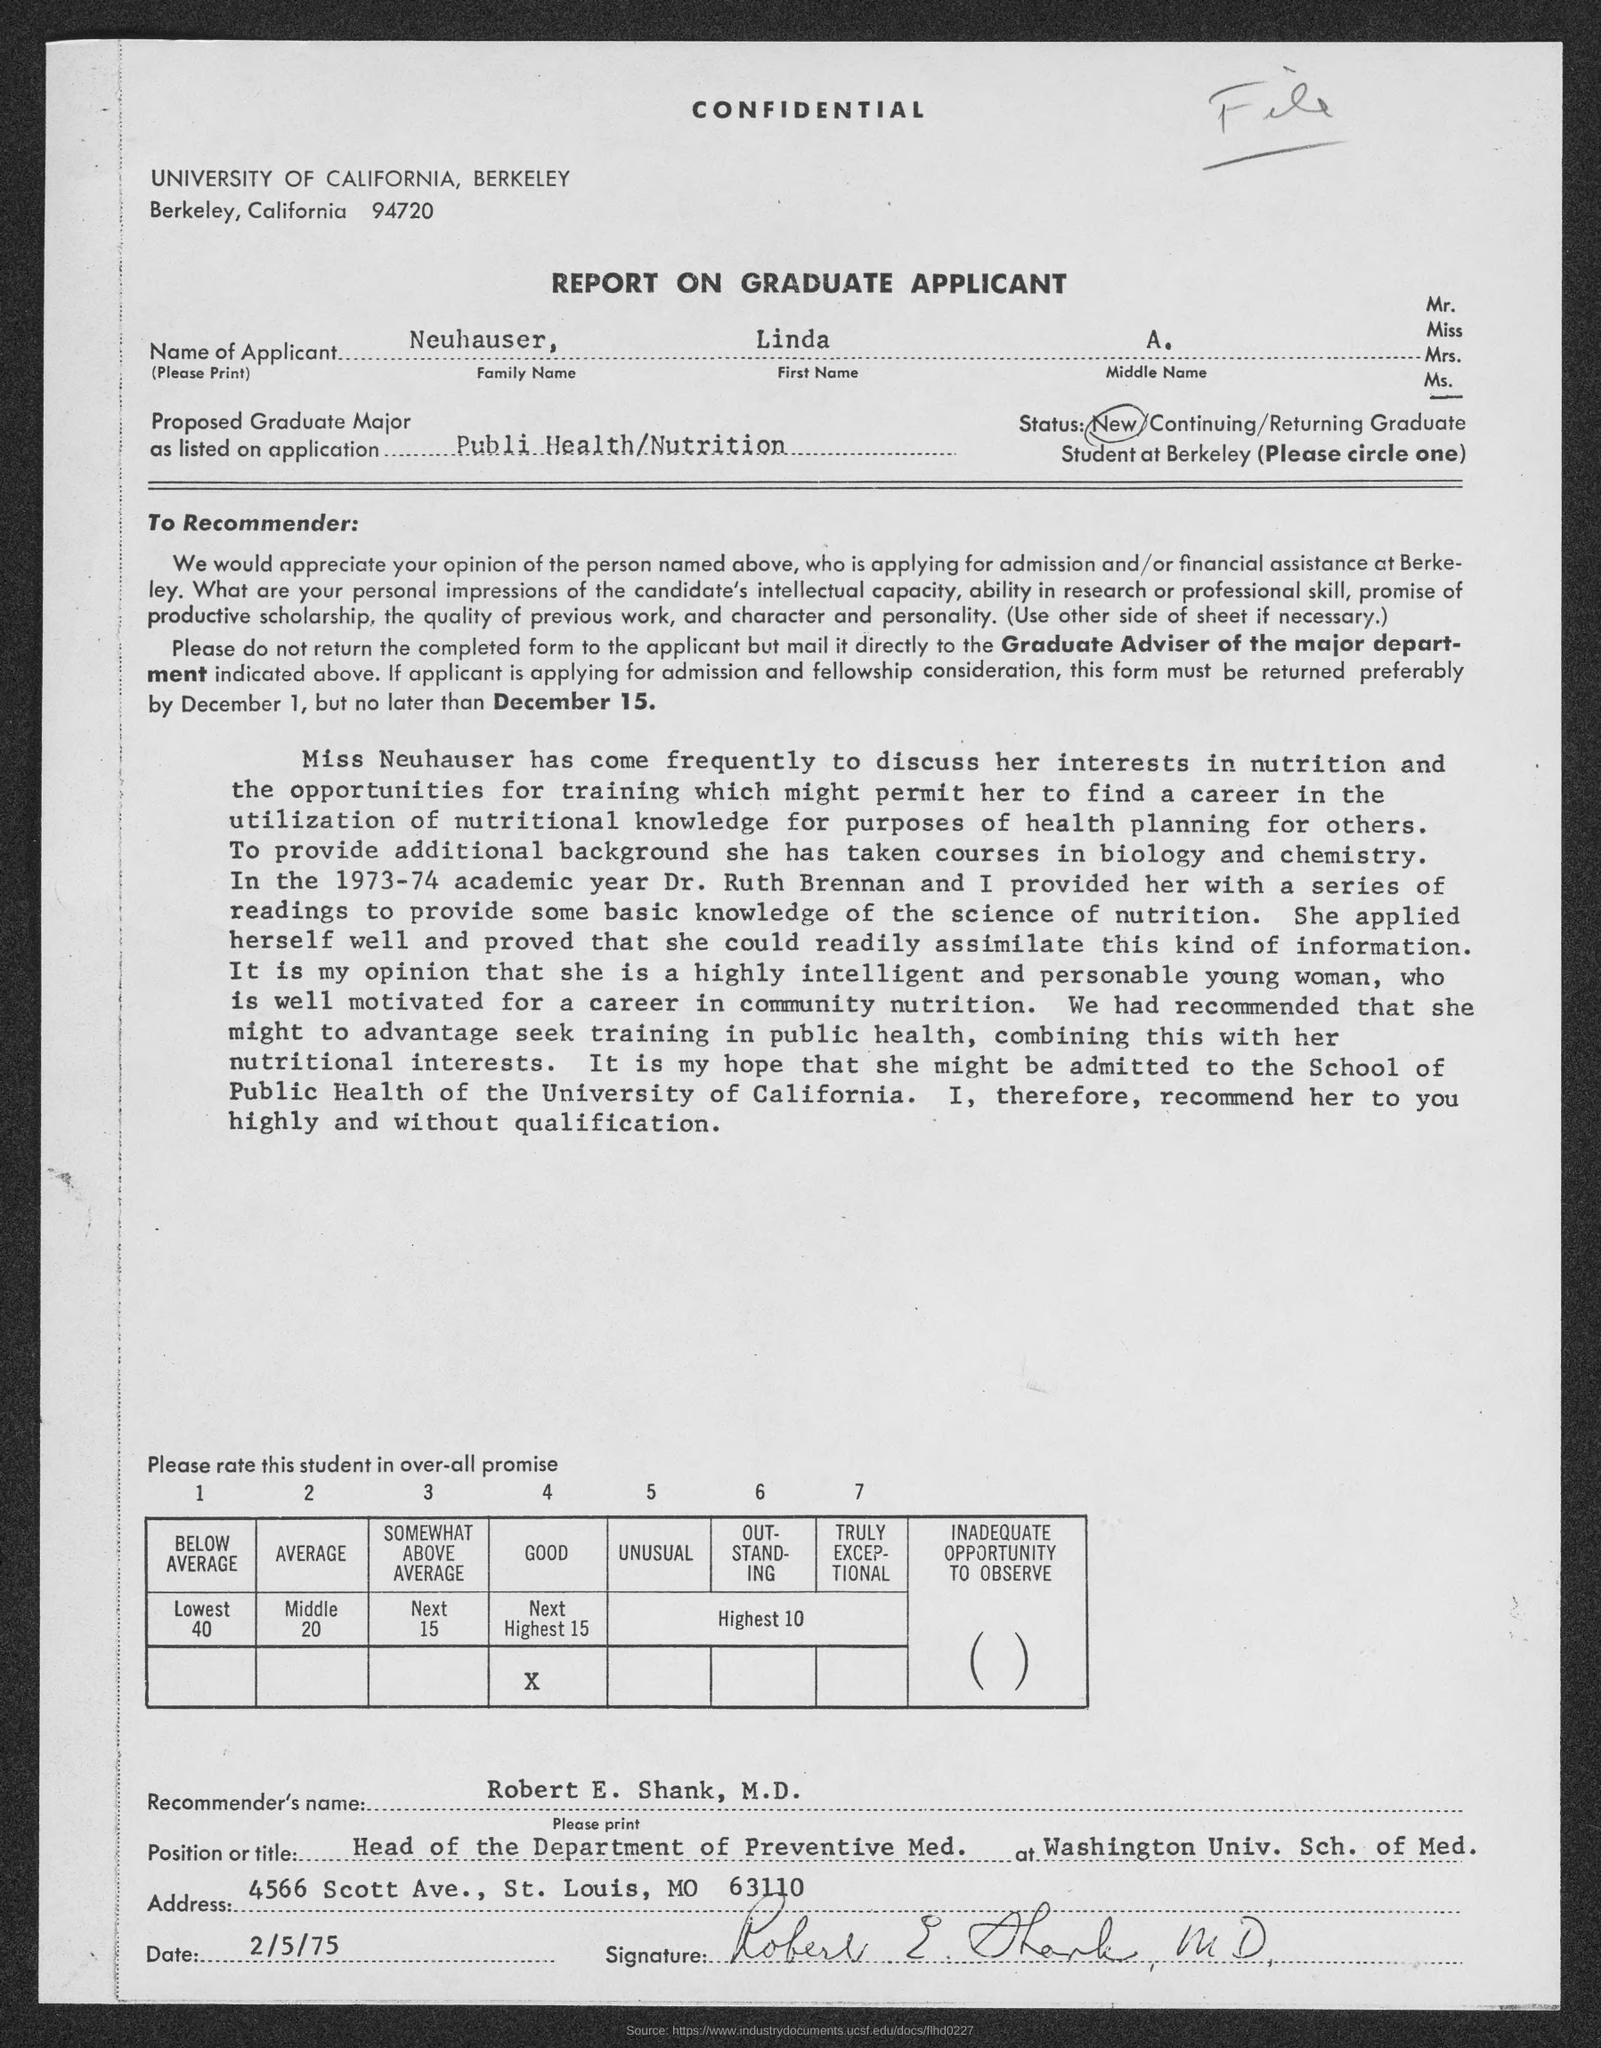Mention a couple of crucial points in this snapshot. The recommender's name, as stated in the application, is Robert E. Shank, M.D. The applicant's name is Neuhauser, Linda A. 